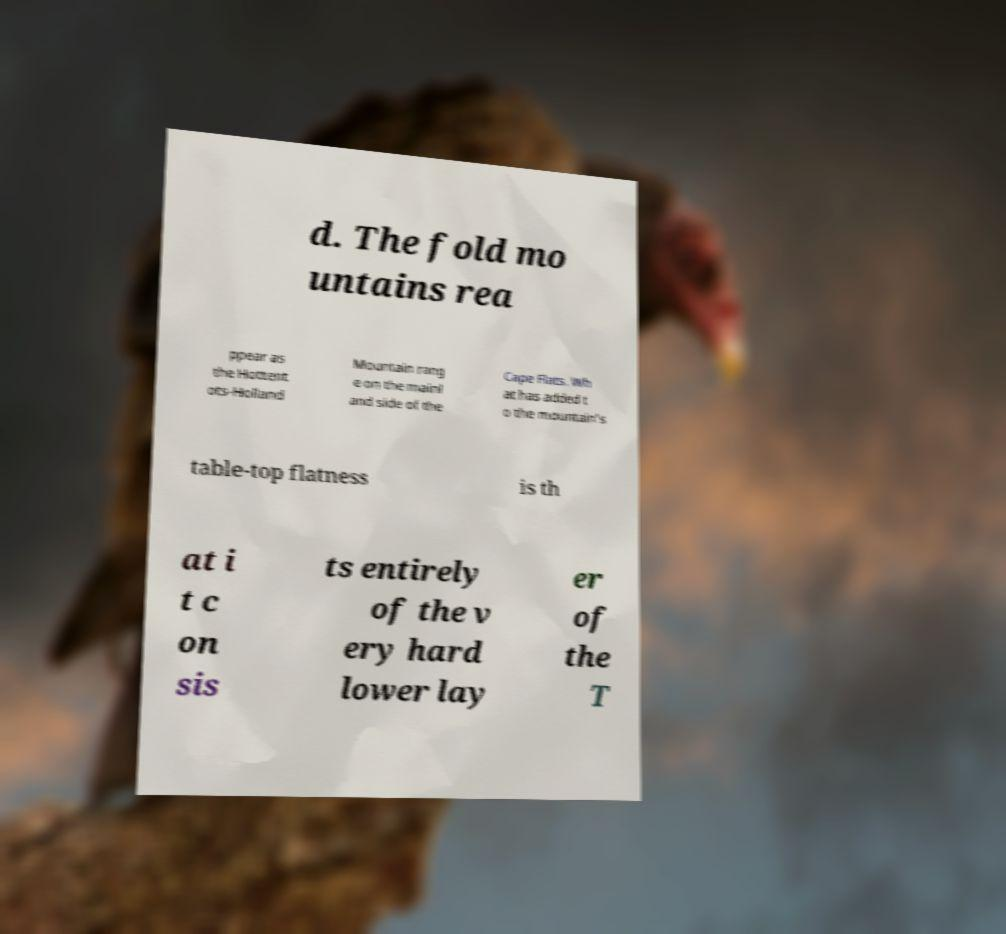Can you read and provide the text displayed in the image?This photo seems to have some interesting text. Can you extract and type it out for me? d. The fold mo untains rea ppear as the Hottent ots-Holland Mountain rang e on the mainl and side of the Cape Flats. Wh at has added t o the mountain's table-top flatness is th at i t c on sis ts entirely of the v ery hard lower lay er of the T 